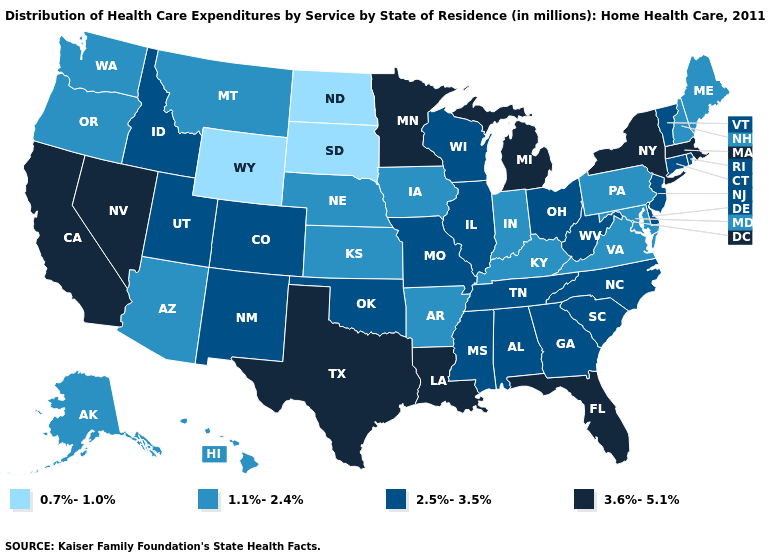Name the states that have a value in the range 0.7%-1.0%?
Give a very brief answer. North Dakota, South Dakota, Wyoming. What is the value of New Jersey?
Short answer required. 2.5%-3.5%. Does Oregon have the lowest value in the USA?
Answer briefly. No. Among the states that border Tennessee , which have the highest value?
Keep it brief. Alabama, Georgia, Mississippi, Missouri, North Carolina. Name the states that have a value in the range 0.7%-1.0%?
Write a very short answer. North Dakota, South Dakota, Wyoming. What is the value of North Dakota?
Short answer required. 0.7%-1.0%. Name the states that have a value in the range 3.6%-5.1%?
Write a very short answer. California, Florida, Louisiana, Massachusetts, Michigan, Minnesota, Nevada, New York, Texas. What is the highest value in states that border Maryland?
Keep it brief. 2.5%-3.5%. Name the states that have a value in the range 2.5%-3.5%?
Keep it brief. Alabama, Colorado, Connecticut, Delaware, Georgia, Idaho, Illinois, Mississippi, Missouri, New Jersey, New Mexico, North Carolina, Ohio, Oklahoma, Rhode Island, South Carolina, Tennessee, Utah, Vermont, West Virginia, Wisconsin. What is the value of New Hampshire?
Be succinct. 1.1%-2.4%. What is the value of Minnesota?
Concise answer only. 3.6%-5.1%. Among the states that border Tennessee , which have the highest value?
Short answer required. Alabama, Georgia, Mississippi, Missouri, North Carolina. Which states have the highest value in the USA?
Quick response, please. California, Florida, Louisiana, Massachusetts, Michigan, Minnesota, Nevada, New York, Texas. What is the value of Rhode Island?
Give a very brief answer. 2.5%-3.5%. Does the first symbol in the legend represent the smallest category?
Be succinct. Yes. 